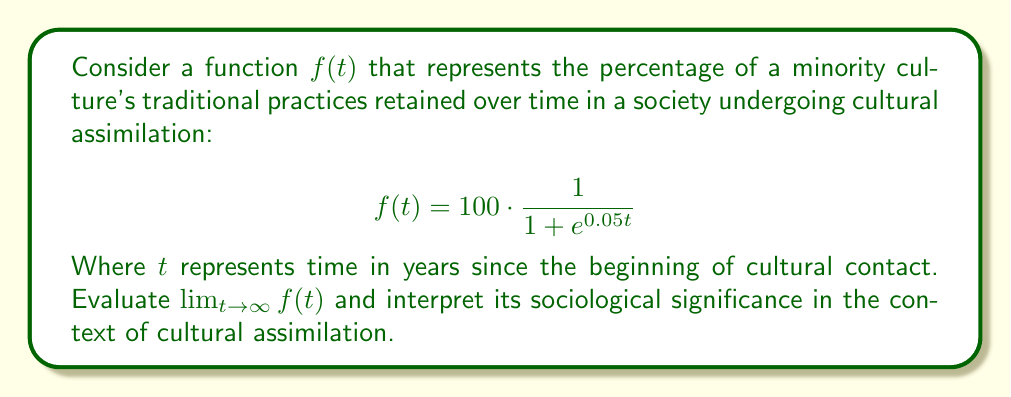Help me with this question. To evaluate this limit, we'll follow these steps:

1) First, let's consider the behavior of $e^{0.05t}$ as $t$ approaches infinity:
   
   As $t \to \infty$, $0.05t \to \infty$, and consequently, $e^{0.05t} \to \infty$

2) Now, let's look at the entire fraction inside $f(t)$:

   $$\frac{1}{1 + e^{0.05t}}$$

   As $e^{0.05t} \to \infty$, this fraction approaches $\frac{1}{\infty}$, which equals 0.

3) Therefore:

   $$\lim_{t \to \infty} f(t) = \lim_{t \to \infty} 100 \cdot \frac{1}{1 + e^{0.05t}} = 100 \cdot 0 = 0$$

Interpretation: 
From a sociological perspective, this limit suggests that in the long run, as time approaches infinity, the percentage of traditional practices retained by the minority culture approaches 0%. This mathematical model implies complete cultural assimilation over an extended period.

However, as a sociology professor skeptical of oversimplified representations of cultural dynamics, we should critically examine this model. It assumes a continuous, inevitable decline in cultural practices, which may not accurately reflect the complexity of cultural interactions, resistance movements, or cultural revival efforts. Real-world cultural assimilation processes are often more nuanced and may not follow such a simplistic mathematical model.
Answer: $\lim_{t \to \infty} f(t) = 0$ 